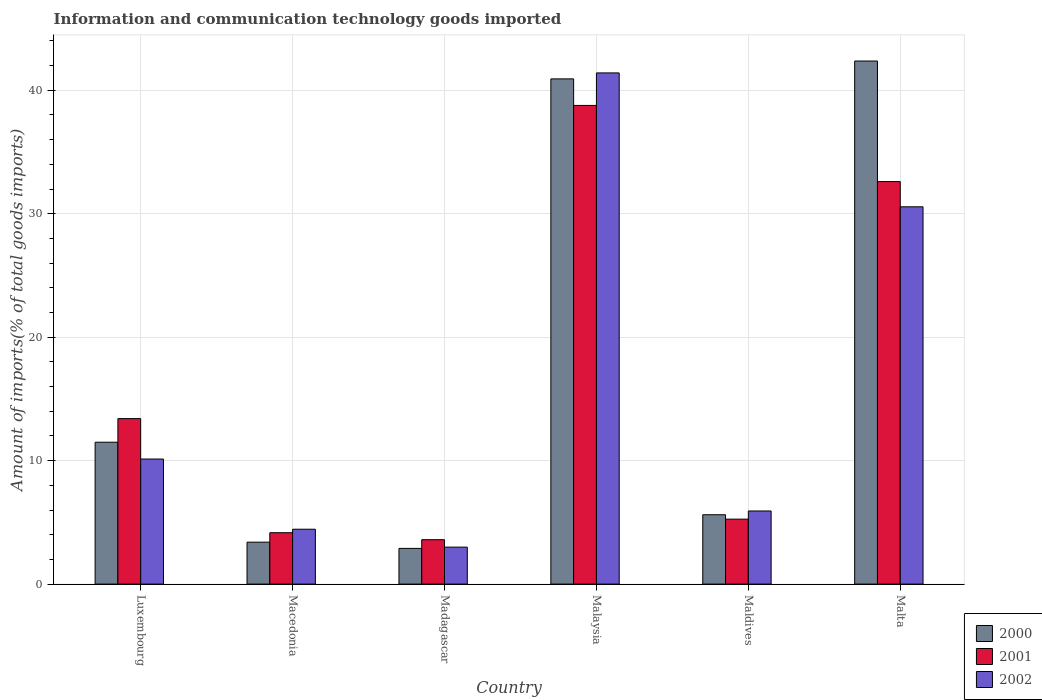How many different coloured bars are there?
Offer a terse response. 3. How many groups of bars are there?
Make the answer very short. 6. Are the number of bars per tick equal to the number of legend labels?
Provide a succinct answer. Yes. How many bars are there on the 1st tick from the right?
Your answer should be very brief. 3. What is the label of the 3rd group of bars from the left?
Ensure brevity in your answer.  Madagascar. In how many cases, is the number of bars for a given country not equal to the number of legend labels?
Provide a succinct answer. 0. What is the amount of goods imported in 2000 in Madagascar?
Your answer should be compact. 2.89. Across all countries, what is the maximum amount of goods imported in 2002?
Offer a very short reply. 41.4. Across all countries, what is the minimum amount of goods imported in 2000?
Provide a succinct answer. 2.89. In which country was the amount of goods imported in 2001 maximum?
Give a very brief answer. Malaysia. In which country was the amount of goods imported in 2002 minimum?
Ensure brevity in your answer.  Madagascar. What is the total amount of goods imported in 2001 in the graph?
Make the answer very short. 97.8. What is the difference between the amount of goods imported in 2000 in Madagascar and that in Malta?
Keep it short and to the point. -39.47. What is the difference between the amount of goods imported in 2001 in Luxembourg and the amount of goods imported in 2000 in Macedonia?
Give a very brief answer. 10.01. What is the average amount of goods imported in 2001 per country?
Keep it short and to the point. 16.3. What is the difference between the amount of goods imported of/in 2000 and amount of goods imported of/in 2002 in Malaysia?
Your answer should be very brief. -0.48. In how many countries, is the amount of goods imported in 2000 greater than 10 %?
Ensure brevity in your answer.  3. What is the ratio of the amount of goods imported in 2001 in Luxembourg to that in Malaysia?
Offer a terse response. 0.35. Is the difference between the amount of goods imported in 2000 in Macedonia and Malta greater than the difference between the amount of goods imported in 2002 in Macedonia and Malta?
Offer a very short reply. No. What is the difference between the highest and the second highest amount of goods imported in 2000?
Provide a succinct answer. -1.45. What is the difference between the highest and the lowest amount of goods imported in 2000?
Ensure brevity in your answer.  39.47. Is the sum of the amount of goods imported in 2002 in Malaysia and Maldives greater than the maximum amount of goods imported in 2000 across all countries?
Provide a succinct answer. Yes. What does the 3rd bar from the left in Macedonia represents?
Provide a short and direct response. 2002. What does the 3rd bar from the right in Macedonia represents?
Give a very brief answer. 2000. How many bars are there?
Give a very brief answer. 18. How many countries are there in the graph?
Give a very brief answer. 6. What is the difference between two consecutive major ticks on the Y-axis?
Keep it short and to the point. 10. Are the values on the major ticks of Y-axis written in scientific E-notation?
Give a very brief answer. No. Does the graph contain grids?
Ensure brevity in your answer.  Yes. What is the title of the graph?
Provide a succinct answer. Information and communication technology goods imported. Does "1988" appear as one of the legend labels in the graph?
Ensure brevity in your answer.  No. What is the label or title of the Y-axis?
Offer a terse response. Amount of imports(% of total goods imports). What is the Amount of imports(% of total goods imports) of 2000 in Luxembourg?
Provide a succinct answer. 11.49. What is the Amount of imports(% of total goods imports) in 2001 in Luxembourg?
Give a very brief answer. 13.4. What is the Amount of imports(% of total goods imports) in 2002 in Luxembourg?
Offer a very short reply. 10.13. What is the Amount of imports(% of total goods imports) in 2000 in Macedonia?
Your answer should be very brief. 3.4. What is the Amount of imports(% of total goods imports) of 2001 in Macedonia?
Offer a terse response. 4.16. What is the Amount of imports(% of total goods imports) of 2002 in Macedonia?
Your answer should be very brief. 4.45. What is the Amount of imports(% of total goods imports) of 2000 in Madagascar?
Your answer should be very brief. 2.89. What is the Amount of imports(% of total goods imports) in 2001 in Madagascar?
Ensure brevity in your answer.  3.6. What is the Amount of imports(% of total goods imports) of 2002 in Madagascar?
Your answer should be very brief. 2.99. What is the Amount of imports(% of total goods imports) of 2000 in Malaysia?
Your response must be concise. 40.92. What is the Amount of imports(% of total goods imports) in 2001 in Malaysia?
Provide a succinct answer. 38.77. What is the Amount of imports(% of total goods imports) in 2002 in Malaysia?
Offer a very short reply. 41.4. What is the Amount of imports(% of total goods imports) of 2000 in Maldives?
Your answer should be very brief. 5.62. What is the Amount of imports(% of total goods imports) of 2001 in Maldives?
Your answer should be compact. 5.26. What is the Amount of imports(% of total goods imports) in 2002 in Maldives?
Provide a succinct answer. 5.92. What is the Amount of imports(% of total goods imports) of 2000 in Malta?
Ensure brevity in your answer.  42.37. What is the Amount of imports(% of total goods imports) in 2001 in Malta?
Give a very brief answer. 32.6. What is the Amount of imports(% of total goods imports) of 2002 in Malta?
Provide a short and direct response. 30.56. Across all countries, what is the maximum Amount of imports(% of total goods imports) of 2000?
Offer a very short reply. 42.37. Across all countries, what is the maximum Amount of imports(% of total goods imports) in 2001?
Keep it short and to the point. 38.77. Across all countries, what is the maximum Amount of imports(% of total goods imports) in 2002?
Provide a succinct answer. 41.4. Across all countries, what is the minimum Amount of imports(% of total goods imports) in 2000?
Offer a terse response. 2.89. Across all countries, what is the minimum Amount of imports(% of total goods imports) in 2001?
Make the answer very short. 3.6. Across all countries, what is the minimum Amount of imports(% of total goods imports) in 2002?
Your response must be concise. 2.99. What is the total Amount of imports(% of total goods imports) in 2000 in the graph?
Your answer should be very brief. 106.69. What is the total Amount of imports(% of total goods imports) of 2001 in the graph?
Give a very brief answer. 97.8. What is the total Amount of imports(% of total goods imports) of 2002 in the graph?
Your answer should be very brief. 95.46. What is the difference between the Amount of imports(% of total goods imports) of 2000 in Luxembourg and that in Macedonia?
Make the answer very short. 8.1. What is the difference between the Amount of imports(% of total goods imports) of 2001 in Luxembourg and that in Macedonia?
Your response must be concise. 9.24. What is the difference between the Amount of imports(% of total goods imports) in 2002 in Luxembourg and that in Macedonia?
Make the answer very short. 5.68. What is the difference between the Amount of imports(% of total goods imports) of 2000 in Luxembourg and that in Madagascar?
Give a very brief answer. 8.6. What is the difference between the Amount of imports(% of total goods imports) in 2001 in Luxembourg and that in Madagascar?
Ensure brevity in your answer.  9.81. What is the difference between the Amount of imports(% of total goods imports) in 2002 in Luxembourg and that in Madagascar?
Your answer should be very brief. 7.14. What is the difference between the Amount of imports(% of total goods imports) in 2000 in Luxembourg and that in Malaysia?
Your answer should be very brief. -29.43. What is the difference between the Amount of imports(% of total goods imports) of 2001 in Luxembourg and that in Malaysia?
Offer a terse response. -25.37. What is the difference between the Amount of imports(% of total goods imports) of 2002 in Luxembourg and that in Malaysia?
Provide a succinct answer. -31.27. What is the difference between the Amount of imports(% of total goods imports) in 2000 in Luxembourg and that in Maldives?
Ensure brevity in your answer.  5.87. What is the difference between the Amount of imports(% of total goods imports) of 2001 in Luxembourg and that in Maldives?
Provide a succinct answer. 8.14. What is the difference between the Amount of imports(% of total goods imports) in 2002 in Luxembourg and that in Maldives?
Your response must be concise. 4.21. What is the difference between the Amount of imports(% of total goods imports) in 2000 in Luxembourg and that in Malta?
Your answer should be very brief. -30.87. What is the difference between the Amount of imports(% of total goods imports) of 2001 in Luxembourg and that in Malta?
Your answer should be compact. -19.2. What is the difference between the Amount of imports(% of total goods imports) in 2002 in Luxembourg and that in Malta?
Offer a very short reply. -20.43. What is the difference between the Amount of imports(% of total goods imports) in 2000 in Macedonia and that in Madagascar?
Offer a terse response. 0.5. What is the difference between the Amount of imports(% of total goods imports) in 2001 in Macedonia and that in Madagascar?
Your response must be concise. 0.57. What is the difference between the Amount of imports(% of total goods imports) of 2002 in Macedonia and that in Madagascar?
Provide a short and direct response. 1.45. What is the difference between the Amount of imports(% of total goods imports) in 2000 in Macedonia and that in Malaysia?
Your answer should be compact. -37.52. What is the difference between the Amount of imports(% of total goods imports) of 2001 in Macedonia and that in Malaysia?
Your answer should be very brief. -34.61. What is the difference between the Amount of imports(% of total goods imports) in 2002 in Macedonia and that in Malaysia?
Offer a very short reply. -36.96. What is the difference between the Amount of imports(% of total goods imports) of 2000 in Macedonia and that in Maldives?
Ensure brevity in your answer.  -2.22. What is the difference between the Amount of imports(% of total goods imports) of 2001 in Macedonia and that in Maldives?
Make the answer very short. -1.1. What is the difference between the Amount of imports(% of total goods imports) in 2002 in Macedonia and that in Maldives?
Make the answer very short. -1.48. What is the difference between the Amount of imports(% of total goods imports) of 2000 in Macedonia and that in Malta?
Make the answer very short. -38.97. What is the difference between the Amount of imports(% of total goods imports) of 2001 in Macedonia and that in Malta?
Your response must be concise. -28.44. What is the difference between the Amount of imports(% of total goods imports) in 2002 in Macedonia and that in Malta?
Give a very brief answer. -26.11. What is the difference between the Amount of imports(% of total goods imports) of 2000 in Madagascar and that in Malaysia?
Provide a succinct answer. -38.03. What is the difference between the Amount of imports(% of total goods imports) of 2001 in Madagascar and that in Malaysia?
Your answer should be compact. -35.17. What is the difference between the Amount of imports(% of total goods imports) of 2002 in Madagascar and that in Malaysia?
Keep it short and to the point. -38.41. What is the difference between the Amount of imports(% of total goods imports) in 2000 in Madagascar and that in Maldives?
Offer a very short reply. -2.73. What is the difference between the Amount of imports(% of total goods imports) in 2001 in Madagascar and that in Maldives?
Your answer should be compact. -1.67. What is the difference between the Amount of imports(% of total goods imports) in 2002 in Madagascar and that in Maldives?
Make the answer very short. -2.93. What is the difference between the Amount of imports(% of total goods imports) in 2000 in Madagascar and that in Malta?
Your answer should be compact. -39.47. What is the difference between the Amount of imports(% of total goods imports) in 2001 in Madagascar and that in Malta?
Make the answer very short. -29.01. What is the difference between the Amount of imports(% of total goods imports) of 2002 in Madagascar and that in Malta?
Keep it short and to the point. -27.57. What is the difference between the Amount of imports(% of total goods imports) of 2000 in Malaysia and that in Maldives?
Your answer should be compact. 35.3. What is the difference between the Amount of imports(% of total goods imports) of 2001 in Malaysia and that in Maldives?
Offer a very short reply. 33.51. What is the difference between the Amount of imports(% of total goods imports) in 2002 in Malaysia and that in Maldives?
Keep it short and to the point. 35.48. What is the difference between the Amount of imports(% of total goods imports) in 2000 in Malaysia and that in Malta?
Provide a succinct answer. -1.45. What is the difference between the Amount of imports(% of total goods imports) of 2001 in Malaysia and that in Malta?
Offer a terse response. 6.17. What is the difference between the Amount of imports(% of total goods imports) in 2002 in Malaysia and that in Malta?
Ensure brevity in your answer.  10.84. What is the difference between the Amount of imports(% of total goods imports) of 2000 in Maldives and that in Malta?
Offer a terse response. -36.75. What is the difference between the Amount of imports(% of total goods imports) in 2001 in Maldives and that in Malta?
Keep it short and to the point. -27.34. What is the difference between the Amount of imports(% of total goods imports) in 2002 in Maldives and that in Malta?
Give a very brief answer. -24.64. What is the difference between the Amount of imports(% of total goods imports) in 2000 in Luxembourg and the Amount of imports(% of total goods imports) in 2001 in Macedonia?
Make the answer very short. 7.33. What is the difference between the Amount of imports(% of total goods imports) in 2000 in Luxembourg and the Amount of imports(% of total goods imports) in 2002 in Macedonia?
Offer a very short reply. 7.05. What is the difference between the Amount of imports(% of total goods imports) of 2001 in Luxembourg and the Amount of imports(% of total goods imports) of 2002 in Macedonia?
Provide a succinct answer. 8.96. What is the difference between the Amount of imports(% of total goods imports) of 2000 in Luxembourg and the Amount of imports(% of total goods imports) of 2001 in Madagascar?
Offer a terse response. 7.9. What is the difference between the Amount of imports(% of total goods imports) of 2000 in Luxembourg and the Amount of imports(% of total goods imports) of 2002 in Madagascar?
Offer a very short reply. 8.5. What is the difference between the Amount of imports(% of total goods imports) in 2001 in Luxembourg and the Amount of imports(% of total goods imports) in 2002 in Madagascar?
Your answer should be compact. 10.41. What is the difference between the Amount of imports(% of total goods imports) of 2000 in Luxembourg and the Amount of imports(% of total goods imports) of 2001 in Malaysia?
Ensure brevity in your answer.  -27.28. What is the difference between the Amount of imports(% of total goods imports) in 2000 in Luxembourg and the Amount of imports(% of total goods imports) in 2002 in Malaysia?
Provide a succinct answer. -29.91. What is the difference between the Amount of imports(% of total goods imports) of 2001 in Luxembourg and the Amount of imports(% of total goods imports) of 2002 in Malaysia?
Your answer should be compact. -28. What is the difference between the Amount of imports(% of total goods imports) of 2000 in Luxembourg and the Amount of imports(% of total goods imports) of 2001 in Maldives?
Keep it short and to the point. 6.23. What is the difference between the Amount of imports(% of total goods imports) of 2000 in Luxembourg and the Amount of imports(% of total goods imports) of 2002 in Maldives?
Provide a succinct answer. 5.57. What is the difference between the Amount of imports(% of total goods imports) in 2001 in Luxembourg and the Amount of imports(% of total goods imports) in 2002 in Maldives?
Keep it short and to the point. 7.48. What is the difference between the Amount of imports(% of total goods imports) of 2000 in Luxembourg and the Amount of imports(% of total goods imports) of 2001 in Malta?
Provide a succinct answer. -21.11. What is the difference between the Amount of imports(% of total goods imports) in 2000 in Luxembourg and the Amount of imports(% of total goods imports) in 2002 in Malta?
Your response must be concise. -19.07. What is the difference between the Amount of imports(% of total goods imports) of 2001 in Luxembourg and the Amount of imports(% of total goods imports) of 2002 in Malta?
Offer a terse response. -17.16. What is the difference between the Amount of imports(% of total goods imports) of 2000 in Macedonia and the Amount of imports(% of total goods imports) of 2001 in Madagascar?
Your answer should be very brief. -0.2. What is the difference between the Amount of imports(% of total goods imports) of 2000 in Macedonia and the Amount of imports(% of total goods imports) of 2002 in Madagascar?
Ensure brevity in your answer.  0.4. What is the difference between the Amount of imports(% of total goods imports) of 2001 in Macedonia and the Amount of imports(% of total goods imports) of 2002 in Madagascar?
Make the answer very short. 1.17. What is the difference between the Amount of imports(% of total goods imports) in 2000 in Macedonia and the Amount of imports(% of total goods imports) in 2001 in Malaysia?
Provide a short and direct response. -35.37. What is the difference between the Amount of imports(% of total goods imports) of 2000 in Macedonia and the Amount of imports(% of total goods imports) of 2002 in Malaysia?
Offer a very short reply. -38.01. What is the difference between the Amount of imports(% of total goods imports) of 2001 in Macedonia and the Amount of imports(% of total goods imports) of 2002 in Malaysia?
Your answer should be compact. -37.24. What is the difference between the Amount of imports(% of total goods imports) of 2000 in Macedonia and the Amount of imports(% of total goods imports) of 2001 in Maldives?
Your answer should be compact. -1.87. What is the difference between the Amount of imports(% of total goods imports) in 2000 in Macedonia and the Amount of imports(% of total goods imports) in 2002 in Maldives?
Keep it short and to the point. -2.53. What is the difference between the Amount of imports(% of total goods imports) in 2001 in Macedonia and the Amount of imports(% of total goods imports) in 2002 in Maldives?
Ensure brevity in your answer.  -1.76. What is the difference between the Amount of imports(% of total goods imports) in 2000 in Macedonia and the Amount of imports(% of total goods imports) in 2001 in Malta?
Your response must be concise. -29.21. What is the difference between the Amount of imports(% of total goods imports) in 2000 in Macedonia and the Amount of imports(% of total goods imports) in 2002 in Malta?
Give a very brief answer. -27.16. What is the difference between the Amount of imports(% of total goods imports) of 2001 in Macedonia and the Amount of imports(% of total goods imports) of 2002 in Malta?
Keep it short and to the point. -26.4. What is the difference between the Amount of imports(% of total goods imports) of 2000 in Madagascar and the Amount of imports(% of total goods imports) of 2001 in Malaysia?
Give a very brief answer. -35.88. What is the difference between the Amount of imports(% of total goods imports) of 2000 in Madagascar and the Amount of imports(% of total goods imports) of 2002 in Malaysia?
Give a very brief answer. -38.51. What is the difference between the Amount of imports(% of total goods imports) of 2001 in Madagascar and the Amount of imports(% of total goods imports) of 2002 in Malaysia?
Your answer should be compact. -37.81. What is the difference between the Amount of imports(% of total goods imports) of 2000 in Madagascar and the Amount of imports(% of total goods imports) of 2001 in Maldives?
Offer a terse response. -2.37. What is the difference between the Amount of imports(% of total goods imports) of 2000 in Madagascar and the Amount of imports(% of total goods imports) of 2002 in Maldives?
Provide a succinct answer. -3.03. What is the difference between the Amount of imports(% of total goods imports) of 2001 in Madagascar and the Amount of imports(% of total goods imports) of 2002 in Maldives?
Keep it short and to the point. -2.33. What is the difference between the Amount of imports(% of total goods imports) in 2000 in Madagascar and the Amount of imports(% of total goods imports) in 2001 in Malta?
Keep it short and to the point. -29.71. What is the difference between the Amount of imports(% of total goods imports) of 2000 in Madagascar and the Amount of imports(% of total goods imports) of 2002 in Malta?
Offer a very short reply. -27.67. What is the difference between the Amount of imports(% of total goods imports) in 2001 in Madagascar and the Amount of imports(% of total goods imports) in 2002 in Malta?
Make the answer very short. -26.96. What is the difference between the Amount of imports(% of total goods imports) in 2000 in Malaysia and the Amount of imports(% of total goods imports) in 2001 in Maldives?
Offer a very short reply. 35.66. What is the difference between the Amount of imports(% of total goods imports) of 2000 in Malaysia and the Amount of imports(% of total goods imports) of 2002 in Maldives?
Provide a short and direct response. 35. What is the difference between the Amount of imports(% of total goods imports) in 2001 in Malaysia and the Amount of imports(% of total goods imports) in 2002 in Maldives?
Ensure brevity in your answer.  32.85. What is the difference between the Amount of imports(% of total goods imports) in 2000 in Malaysia and the Amount of imports(% of total goods imports) in 2001 in Malta?
Provide a succinct answer. 8.32. What is the difference between the Amount of imports(% of total goods imports) in 2000 in Malaysia and the Amount of imports(% of total goods imports) in 2002 in Malta?
Ensure brevity in your answer.  10.36. What is the difference between the Amount of imports(% of total goods imports) in 2001 in Malaysia and the Amount of imports(% of total goods imports) in 2002 in Malta?
Keep it short and to the point. 8.21. What is the difference between the Amount of imports(% of total goods imports) of 2000 in Maldives and the Amount of imports(% of total goods imports) of 2001 in Malta?
Offer a terse response. -26.99. What is the difference between the Amount of imports(% of total goods imports) in 2000 in Maldives and the Amount of imports(% of total goods imports) in 2002 in Malta?
Give a very brief answer. -24.94. What is the difference between the Amount of imports(% of total goods imports) of 2001 in Maldives and the Amount of imports(% of total goods imports) of 2002 in Malta?
Ensure brevity in your answer.  -25.3. What is the average Amount of imports(% of total goods imports) of 2000 per country?
Your answer should be compact. 17.78. What is the average Amount of imports(% of total goods imports) of 2001 per country?
Provide a succinct answer. 16.3. What is the average Amount of imports(% of total goods imports) in 2002 per country?
Your answer should be very brief. 15.91. What is the difference between the Amount of imports(% of total goods imports) of 2000 and Amount of imports(% of total goods imports) of 2001 in Luxembourg?
Give a very brief answer. -1.91. What is the difference between the Amount of imports(% of total goods imports) of 2000 and Amount of imports(% of total goods imports) of 2002 in Luxembourg?
Ensure brevity in your answer.  1.36. What is the difference between the Amount of imports(% of total goods imports) in 2001 and Amount of imports(% of total goods imports) in 2002 in Luxembourg?
Make the answer very short. 3.27. What is the difference between the Amount of imports(% of total goods imports) in 2000 and Amount of imports(% of total goods imports) in 2001 in Macedonia?
Keep it short and to the point. -0.77. What is the difference between the Amount of imports(% of total goods imports) in 2000 and Amount of imports(% of total goods imports) in 2002 in Macedonia?
Your answer should be compact. -1.05. What is the difference between the Amount of imports(% of total goods imports) in 2001 and Amount of imports(% of total goods imports) in 2002 in Macedonia?
Offer a terse response. -0.28. What is the difference between the Amount of imports(% of total goods imports) in 2000 and Amount of imports(% of total goods imports) in 2001 in Madagascar?
Provide a short and direct response. -0.7. What is the difference between the Amount of imports(% of total goods imports) in 2000 and Amount of imports(% of total goods imports) in 2002 in Madagascar?
Provide a succinct answer. -0.1. What is the difference between the Amount of imports(% of total goods imports) of 2001 and Amount of imports(% of total goods imports) of 2002 in Madagascar?
Your answer should be compact. 0.6. What is the difference between the Amount of imports(% of total goods imports) in 2000 and Amount of imports(% of total goods imports) in 2001 in Malaysia?
Provide a succinct answer. 2.15. What is the difference between the Amount of imports(% of total goods imports) in 2000 and Amount of imports(% of total goods imports) in 2002 in Malaysia?
Ensure brevity in your answer.  -0.48. What is the difference between the Amount of imports(% of total goods imports) in 2001 and Amount of imports(% of total goods imports) in 2002 in Malaysia?
Your answer should be very brief. -2.63. What is the difference between the Amount of imports(% of total goods imports) of 2000 and Amount of imports(% of total goods imports) of 2001 in Maldives?
Ensure brevity in your answer.  0.36. What is the difference between the Amount of imports(% of total goods imports) in 2000 and Amount of imports(% of total goods imports) in 2002 in Maldives?
Give a very brief answer. -0.31. What is the difference between the Amount of imports(% of total goods imports) in 2001 and Amount of imports(% of total goods imports) in 2002 in Maldives?
Offer a very short reply. -0.66. What is the difference between the Amount of imports(% of total goods imports) of 2000 and Amount of imports(% of total goods imports) of 2001 in Malta?
Provide a short and direct response. 9.76. What is the difference between the Amount of imports(% of total goods imports) of 2000 and Amount of imports(% of total goods imports) of 2002 in Malta?
Make the answer very short. 11.81. What is the difference between the Amount of imports(% of total goods imports) of 2001 and Amount of imports(% of total goods imports) of 2002 in Malta?
Your answer should be very brief. 2.04. What is the ratio of the Amount of imports(% of total goods imports) in 2000 in Luxembourg to that in Macedonia?
Your response must be concise. 3.38. What is the ratio of the Amount of imports(% of total goods imports) of 2001 in Luxembourg to that in Macedonia?
Provide a short and direct response. 3.22. What is the ratio of the Amount of imports(% of total goods imports) of 2002 in Luxembourg to that in Macedonia?
Provide a short and direct response. 2.28. What is the ratio of the Amount of imports(% of total goods imports) of 2000 in Luxembourg to that in Madagascar?
Your response must be concise. 3.97. What is the ratio of the Amount of imports(% of total goods imports) in 2001 in Luxembourg to that in Madagascar?
Ensure brevity in your answer.  3.73. What is the ratio of the Amount of imports(% of total goods imports) of 2002 in Luxembourg to that in Madagascar?
Offer a terse response. 3.38. What is the ratio of the Amount of imports(% of total goods imports) of 2000 in Luxembourg to that in Malaysia?
Provide a short and direct response. 0.28. What is the ratio of the Amount of imports(% of total goods imports) in 2001 in Luxembourg to that in Malaysia?
Give a very brief answer. 0.35. What is the ratio of the Amount of imports(% of total goods imports) of 2002 in Luxembourg to that in Malaysia?
Offer a terse response. 0.24. What is the ratio of the Amount of imports(% of total goods imports) of 2000 in Luxembourg to that in Maldives?
Make the answer very short. 2.05. What is the ratio of the Amount of imports(% of total goods imports) of 2001 in Luxembourg to that in Maldives?
Provide a succinct answer. 2.55. What is the ratio of the Amount of imports(% of total goods imports) in 2002 in Luxembourg to that in Maldives?
Keep it short and to the point. 1.71. What is the ratio of the Amount of imports(% of total goods imports) of 2000 in Luxembourg to that in Malta?
Ensure brevity in your answer.  0.27. What is the ratio of the Amount of imports(% of total goods imports) of 2001 in Luxembourg to that in Malta?
Offer a very short reply. 0.41. What is the ratio of the Amount of imports(% of total goods imports) of 2002 in Luxembourg to that in Malta?
Provide a succinct answer. 0.33. What is the ratio of the Amount of imports(% of total goods imports) in 2000 in Macedonia to that in Madagascar?
Keep it short and to the point. 1.17. What is the ratio of the Amount of imports(% of total goods imports) of 2001 in Macedonia to that in Madagascar?
Your answer should be very brief. 1.16. What is the ratio of the Amount of imports(% of total goods imports) in 2002 in Macedonia to that in Madagascar?
Provide a succinct answer. 1.48. What is the ratio of the Amount of imports(% of total goods imports) of 2000 in Macedonia to that in Malaysia?
Your response must be concise. 0.08. What is the ratio of the Amount of imports(% of total goods imports) in 2001 in Macedonia to that in Malaysia?
Your response must be concise. 0.11. What is the ratio of the Amount of imports(% of total goods imports) of 2002 in Macedonia to that in Malaysia?
Give a very brief answer. 0.11. What is the ratio of the Amount of imports(% of total goods imports) of 2000 in Macedonia to that in Maldives?
Your response must be concise. 0.6. What is the ratio of the Amount of imports(% of total goods imports) in 2001 in Macedonia to that in Maldives?
Offer a terse response. 0.79. What is the ratio of the Amount of imports(% of total goods imports) in 2002 in Macedonia to that in Maldives?
Offer a very short reply. 0.75. What is the ratio of the Amount of imports(% of total goods imports) in 2000 in Macedonia to that in Malta?
Offer a terse response. 0.08. What is the ratio of the Amount of imports(% of total goods imports) of 2001 in Macedonia to that in Malta?
Your answer should be compact. 0.13. What is the ratio of the Amount of imports(% of total goods imports) in 2002 in Macedonia to that in Malta?
Offer a terse response. 0.15. What is the ratio of the Amount of imports(% of total goods imports) in 2000 in Madagascar to that in Malaysia?
Your answer should be compact. 0.07. What is the ratio of the Amount of imports(% of total goods imports) in 2001 in Madagascar to that in Malaysia?
Make the answer very short. 0.09. What is the ratio of the Amount of imports(% of total goods imports) of 2002 in Madagascar to that in Malaysia?
Provide a succinct answer. 0.07. What is the ratio of the Amount of imports(% of total goods imports) in 2000 in Madagascar to that in Maldives?
Offer a terse response. 0.51. What is the ratio of the Amount of imports(% of total goods imports) in 2001 in Madagascar to that in Maldives?
Ensure brevity in your answer.  0.68. What is the ratio of the Amount of imports(% of total goods imports) of 2002 in Madagascar to that in Maldives?
Give a very brief answer. 0.51. What is the ratio of the Amount of imports(% of total goods imports) of 2000 in Madagascar to that in Malta?
Your response must be concise. 0.07. What is the ratio of the Amount of imports(% of total goods imports) in 2001 in Madagascar to that in Malta?
Offer a very short reply. 0.11. What is the ratio of the Amount of imports(% of total goods imports) in 2002 in Madagascar to that in Malta?
Make the answer very short. 0.1. What is the ratio of the Amount of imports(% of total goods imports) in 2000 in Malaysia to that in Maldives?
Give a very brief answer. 7.28. What is the ratio of the Amount of imports(% of total goods imports) of 2001 in Malaysia to that in Maldives?
Keep it short and to the point. 7.37. What is the ratio of the Amount of imports(% of total goods imports) of 2002 in Malaysia to that in Maldives?
Make the answer very short. 6.99. What is the ratio of the Amount of imports(% of total goods imports) of 2000 in Malaysia to that in Malta?
Keep it short and to the point. 0.97. What is the ratio of the Amount of imports(% of total goods imports) in 2001 in Malaysia to that in Malta?
Keep it short and to the point. 1.19. What is the ratio of the Amount of imports(% of total goods imports) of 2002 in Malaysia to that in Malta?
Your response must be concise. 1.35. What is the ratio of the Amount of imports(% of total goods imports) in 2000 in Maldives to that in Malta?
Ensure brevity in your answer.  0.13. What is the ratio of the Amount of imports(% of total goods imports) in 2001 in Maldives to that in Malta?
Make the answer very short. 0.16. What is the ratio of the Amount of imports(% of total goods imports) of 2002 in Maldives to that in Malta?
Make the answer very short. 0.19. What is the difference between the highest and the second highest Amount of imports(% of total goods imports) of 2000?
Provide a succinct answer. 1.45. What is the difference between the highest and the second highest Amount of imports(% of total goods imports) in 2001?
Give a very brief answer. 6.17. What is the difference between the highest and the second highest Amount of imports(% of total goods imports) of 2002?
Provide a succinct answer. 10.84. What is the difference between the highest and the lowest Amount of imports(% of total goods imports) in 2000?
Ensure brevity in your answer.  39.47. What is the difference between the highest and the lowest Amount of imports(% of total goods imports) of 2001?
Provide a succinct answer. 35.17. What is the difference between the highest and the lowest Amount of imports(% of total goods imports) of 2002?
Keep it short and to the point. 38.41. 